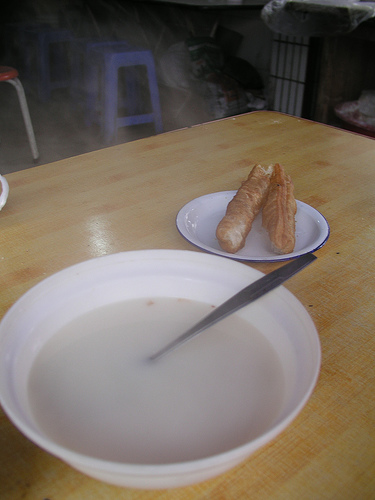<image>
Is there a plate next to the bread? No. The plate is not positioned next to the bread. They are located in different areas of the scene. 